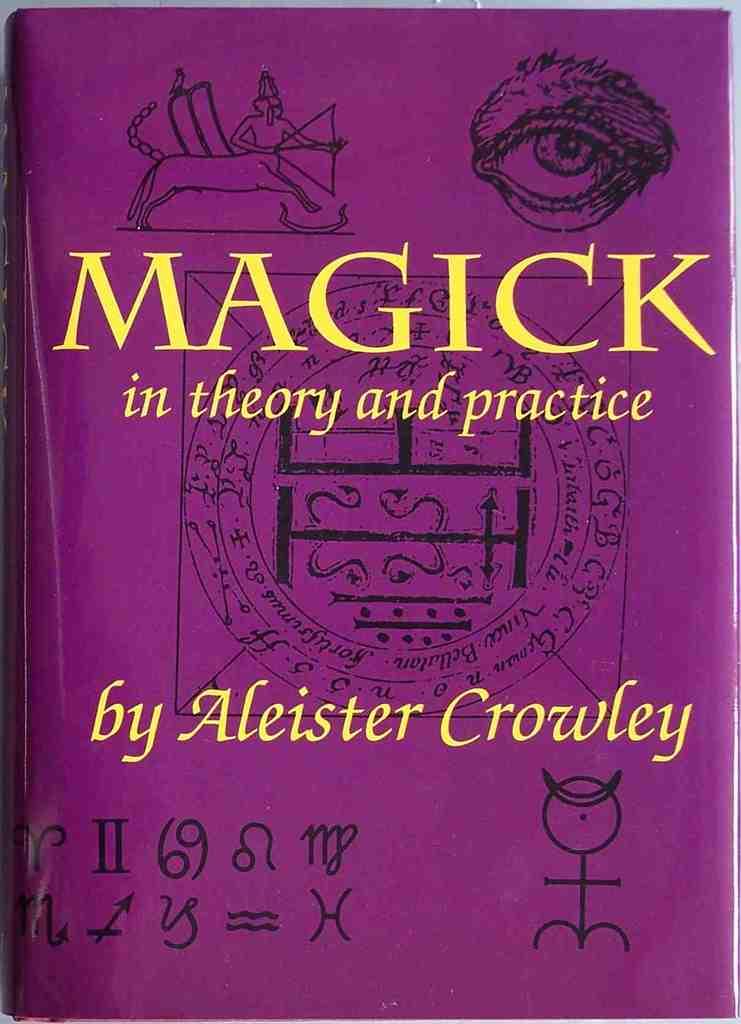What is the title of this book?
Give a very brief answer. Magick in theory and practice. 